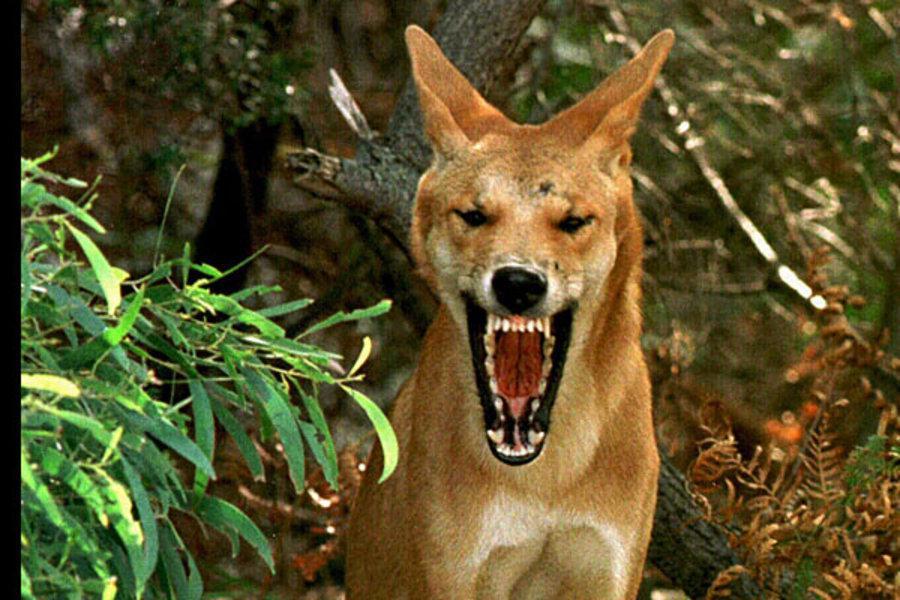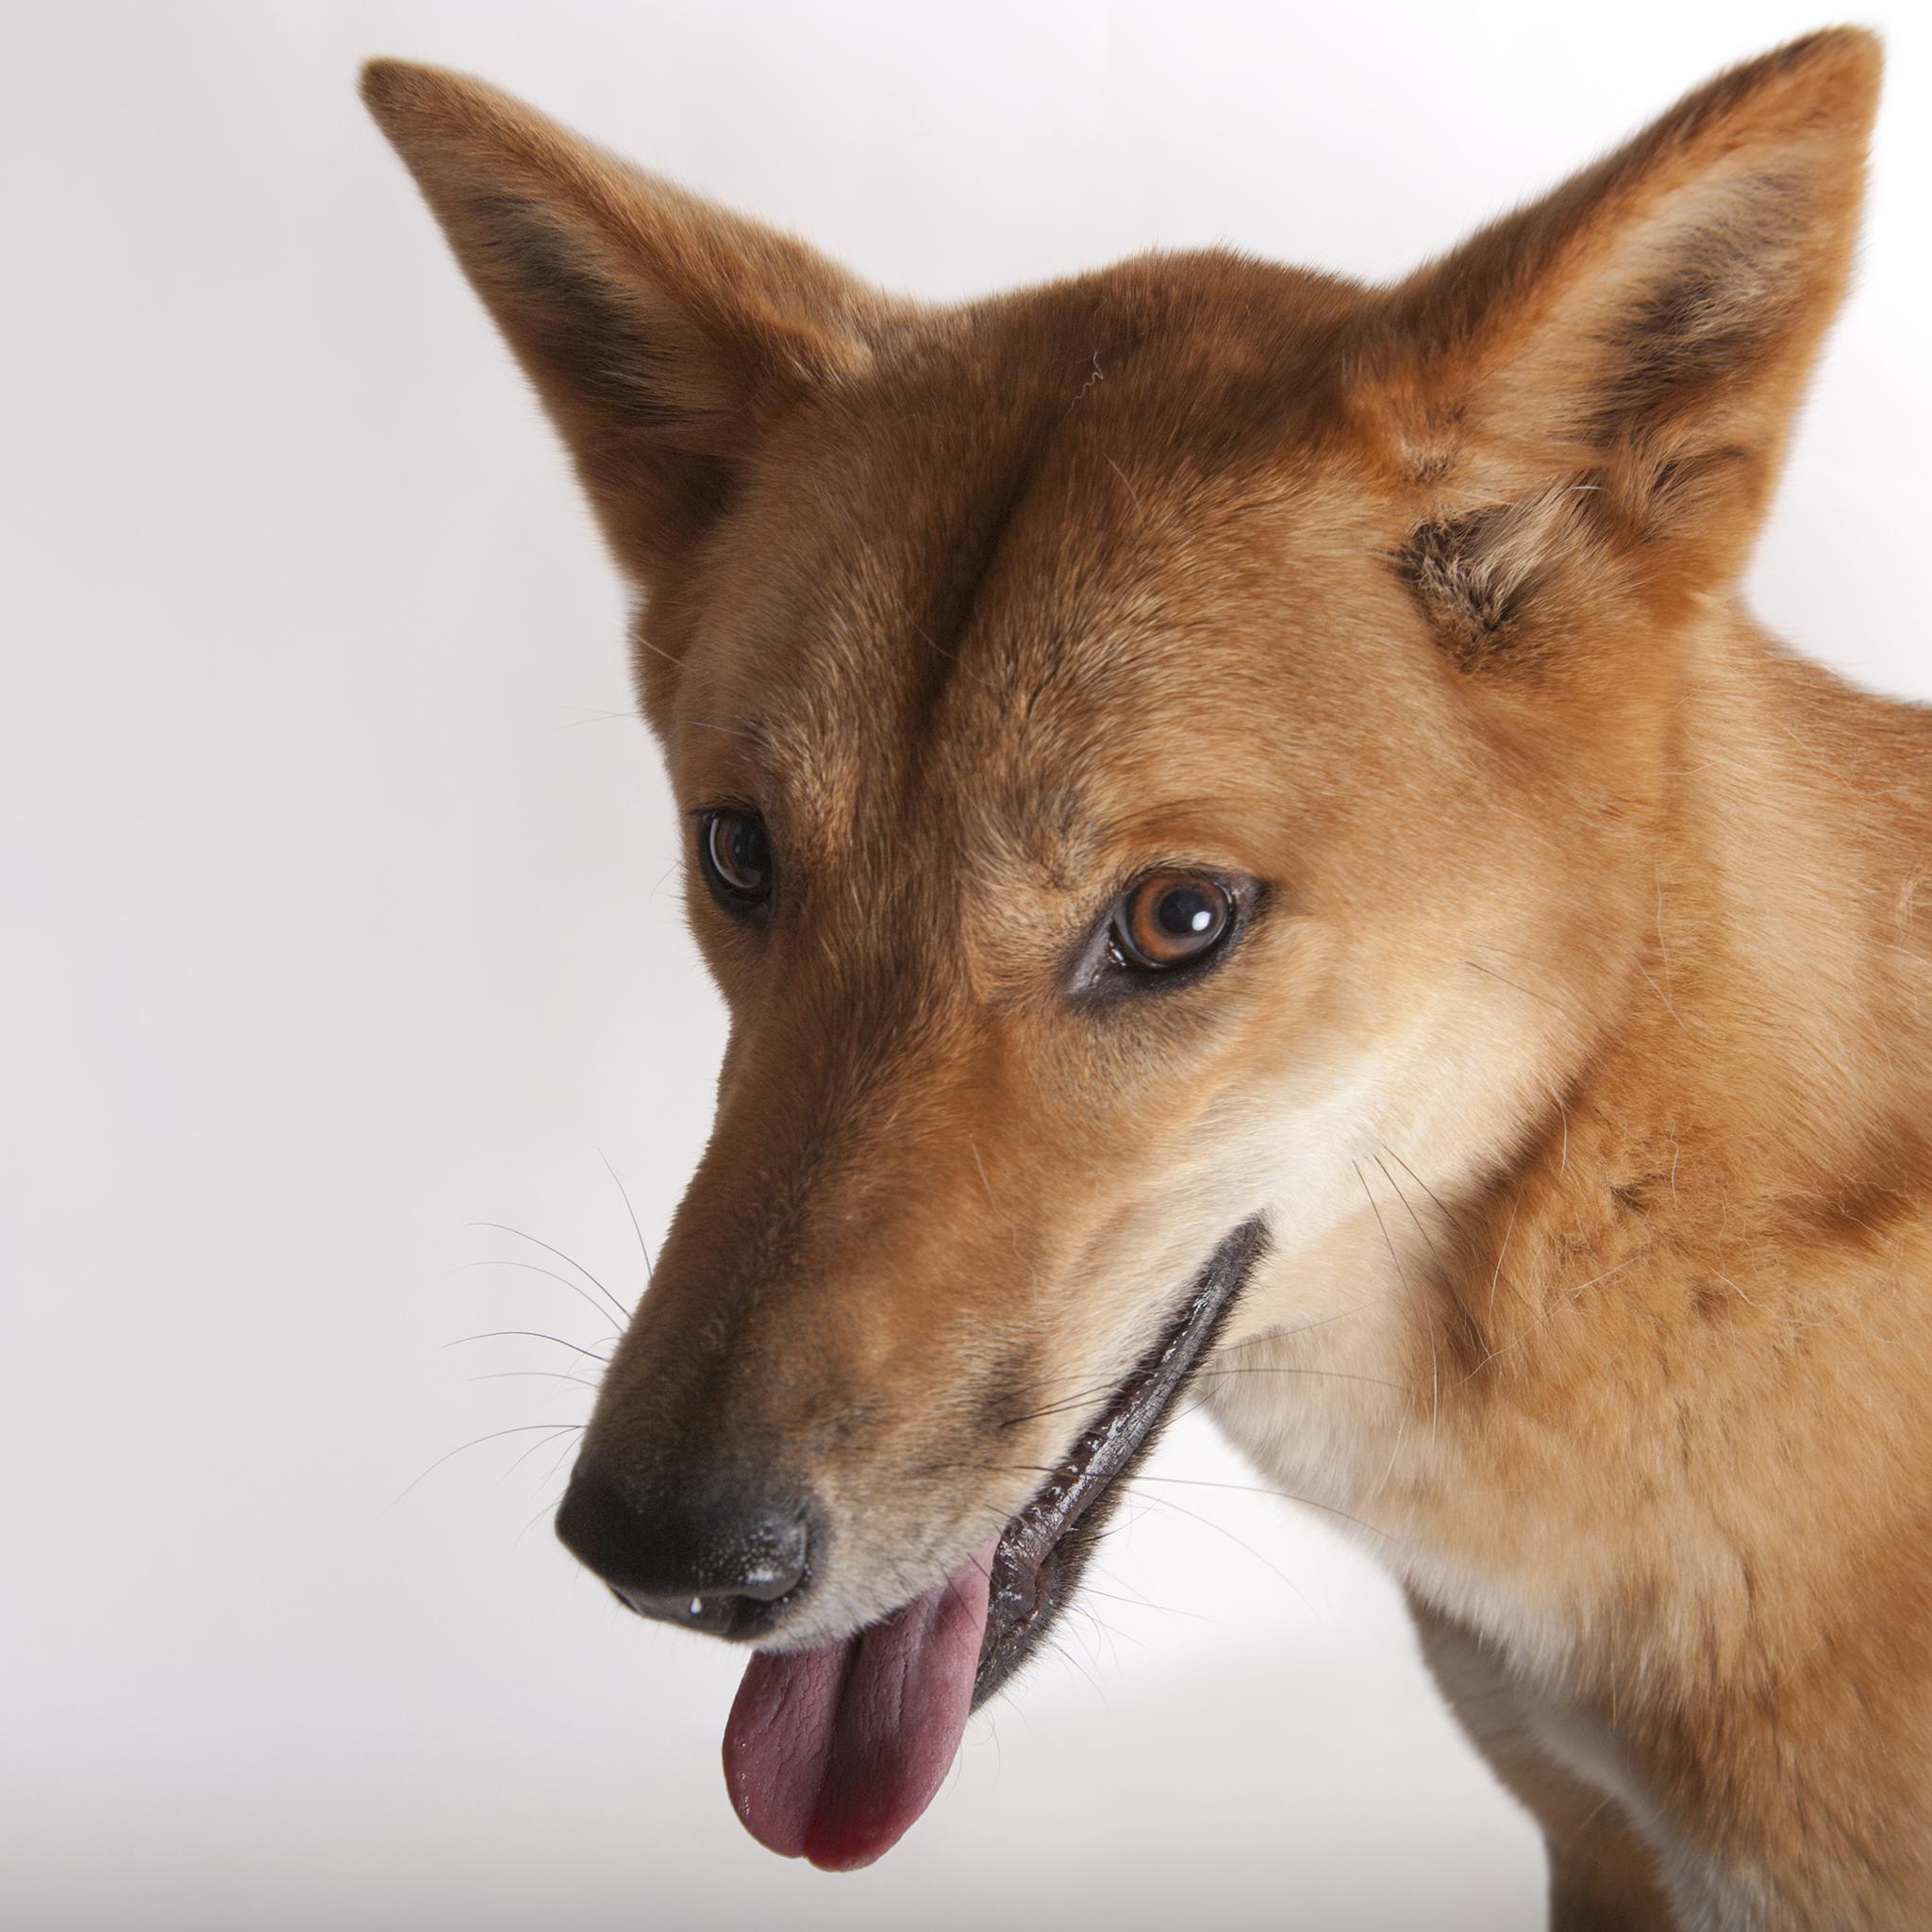The first image is the image on the left, the second image is the image on the right. For the images displayed, is the sentence "There is at least one image there is a single yellow and white dog facing right with their heads turned left." factually correct? Answer yes or no. No. 